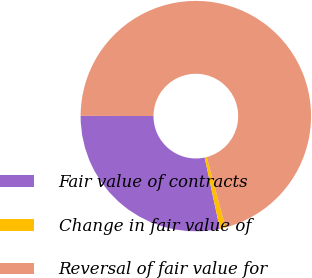Convert chart. <chart><loc_0><loc_0><loc_500><loc_500><pie_chart><fcel>Fair value of contracts<fcel>Change in fair value of<fcel>Reversal of fair value for<nl><fcel>28.38%<fcel>0.8%<fcel>70.82%<nl></chart> 